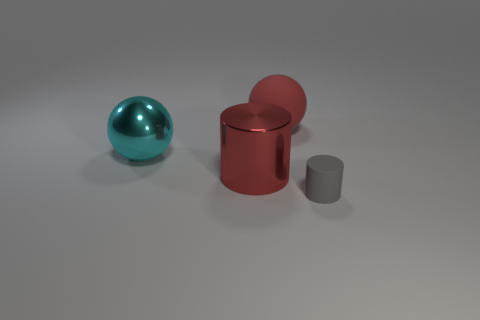There is a large object that is behind the metallic sphere; is it the same color as the metal cylinder?
Your response must be concise. Yes. Is there any other thing of the same color as the large cylinder?
Offer a very short reply. Yes. The matte thing that is the same color as the metal cylinder is what shape?
Offer a very short reply. Sphere. There is a big metallic object that is in front of the big metal ball; what is its shape?
Offer a terse response. Cylinder. What number of objects are right of the red shiny cylinder and in front of the large cyan sphere?
Give a very brief answer. 1. Is there a large cylinder that has the same material as the big cyan object?
Ensure brevity in your answer.  Yes. The object that is the same color as the big matte ball is what size?
Your response must be concise. Large. How many cylinders are red metal things or cyan things?
Keep it short and to the point. 1. The cyan metal thing is what size?
Your response must be concise. Large. There is a red matte object; how many large red metal objects are on the left side of it?
Your answer should be very brief. 1. 